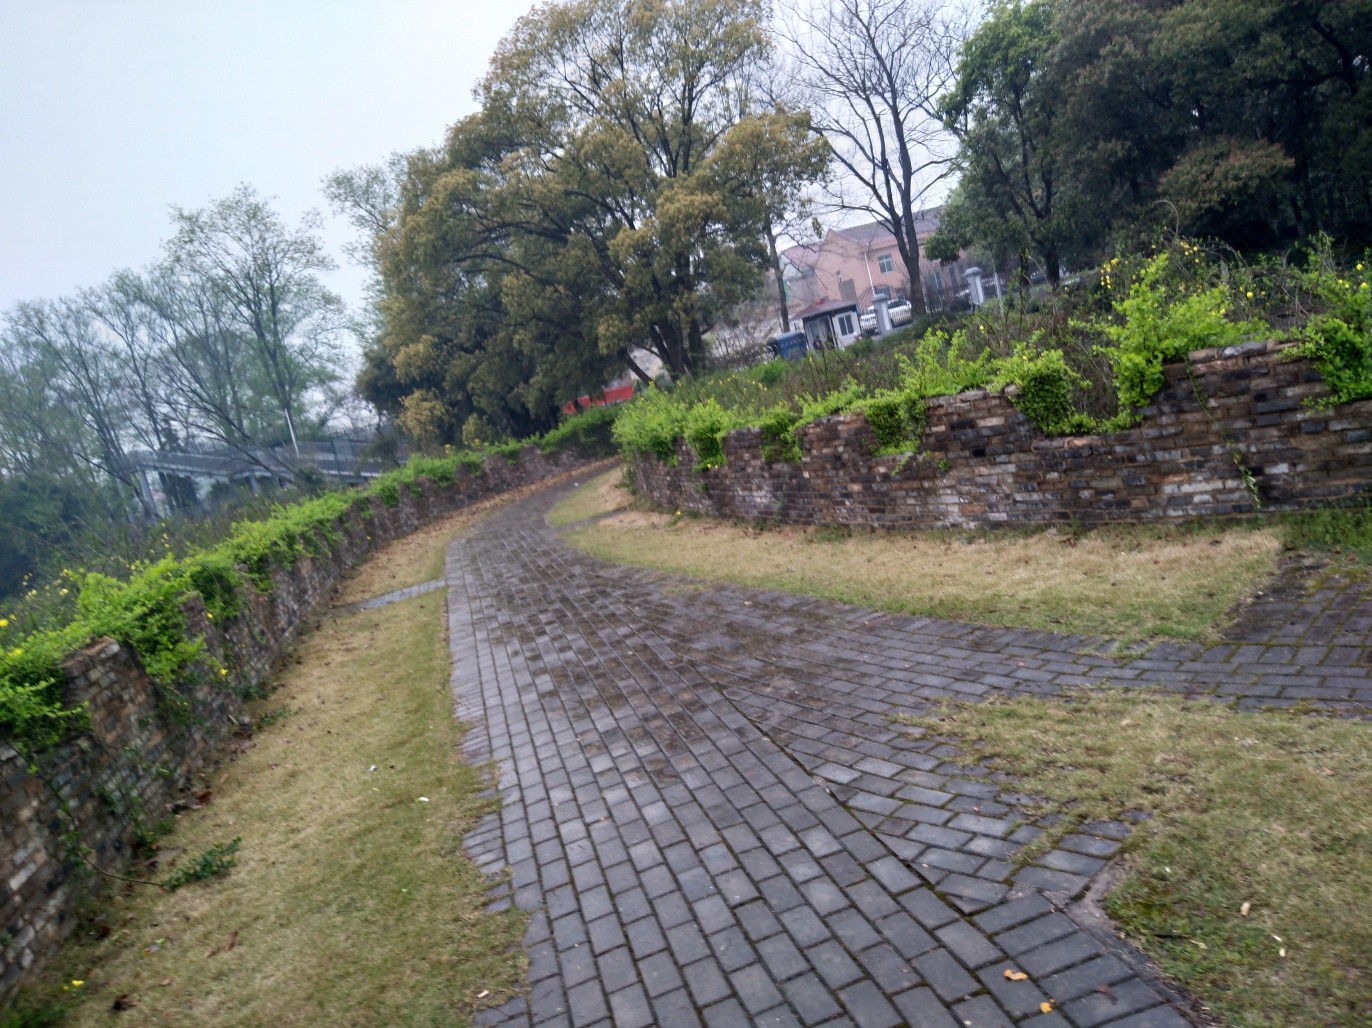Can you infer the weather conditions when this photo was taken? The photo appears to have been taken on an overcast day, judging by the lack of shadows and the diffuse light. There seems to be a slight mist in the air, which might suggest recent rain or an approaching weather front. The wet surface of the cobblestone path reinforces the idea that it might have rained shortly before the photo was taken. 